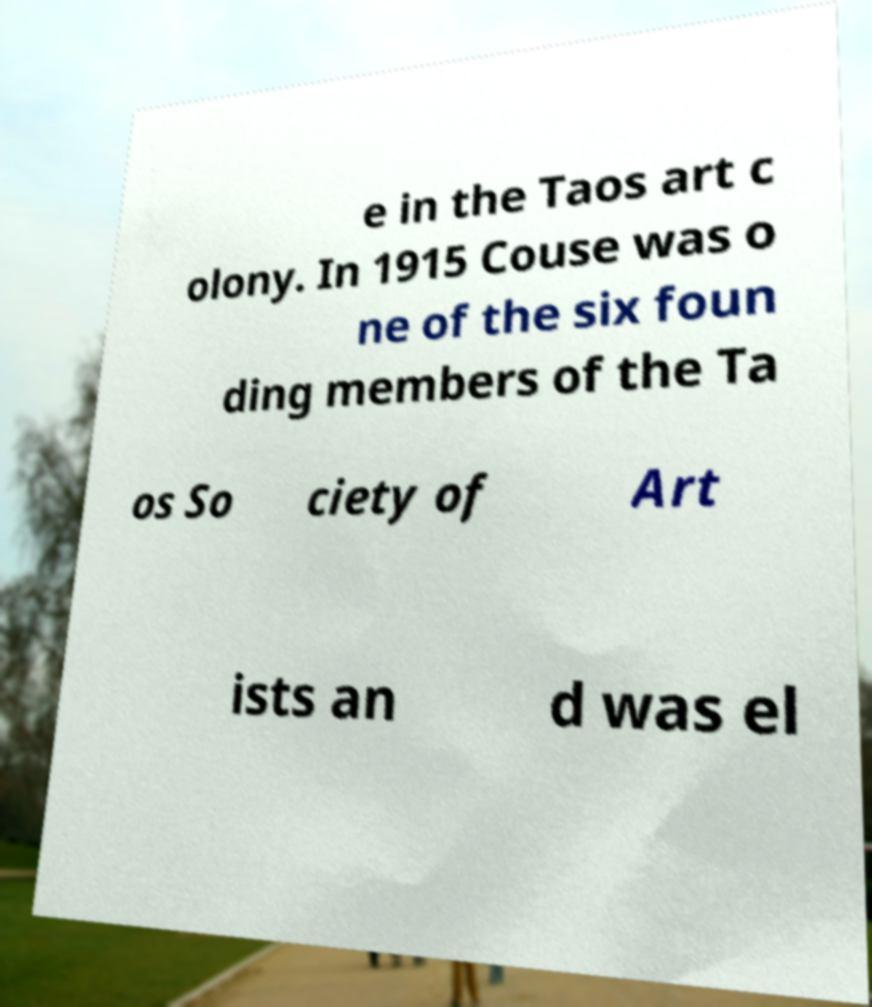There's text embedded in this image that I need extracted. Can you transcribe it verbatim? e in the Taos art c olony. In 1915 Couse was o ne of the six foun ding members of the Ta os So ciety of Art ists an d was el 